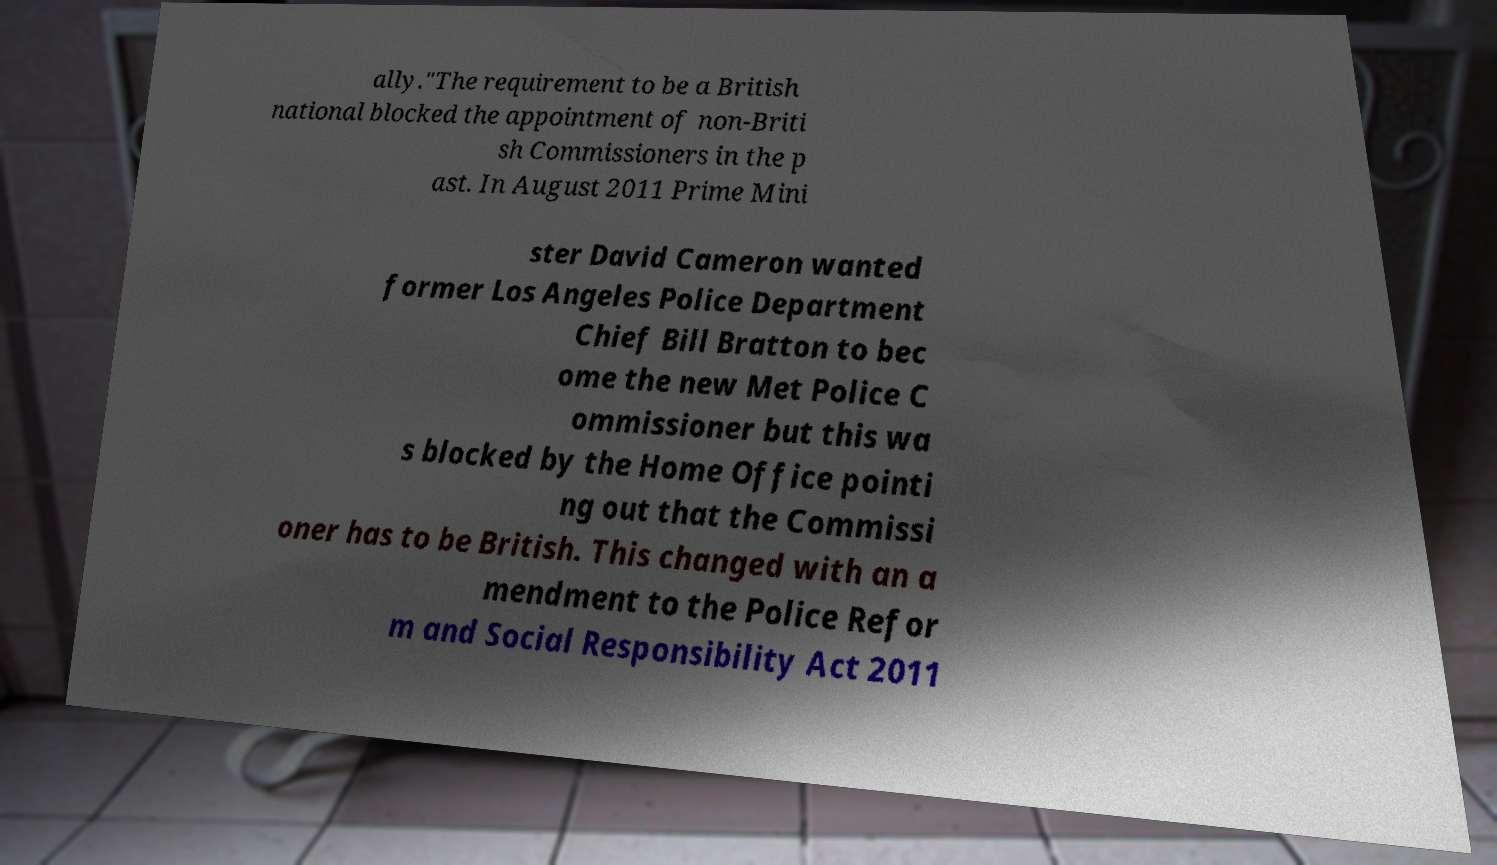There's text embedded in this image that I need extracted. Can you transcribe it verbatim? ally."The requirement to be a British national blocked the appointment of non-Briti sh Commissioners in the p ast. In August 2011 Prime Mini ster David Cameron wanted former Los Angeles Police Department Chief Bill Bratton to bec ome the new Met Police C ommissioner but this wa s blocked by the Home Office pointi ng out that the Commissi oner has to be British. This changed with an a mendment to the Police Refor m and Social Responsibility Act 2011 